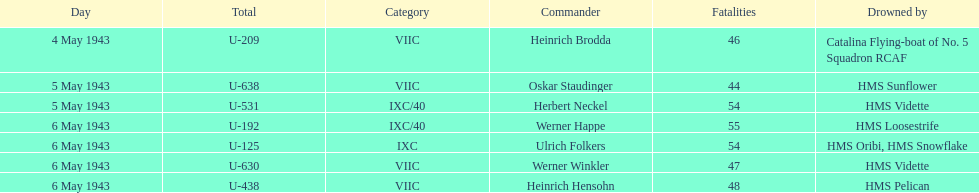Who were the captains in the ons 5 convoy? Heinrich Brodda, Oskar Staudinger, Herbert Neckel, Werner Happe, Ulrich Folkers, Werner Winkler, Heinrich Hensohn. Which ones lost their u-boat on may 5? Oskar Staudinger, Herbert Neckel. Of those, which one is not oskar staudinger? Herbert Neckel. 